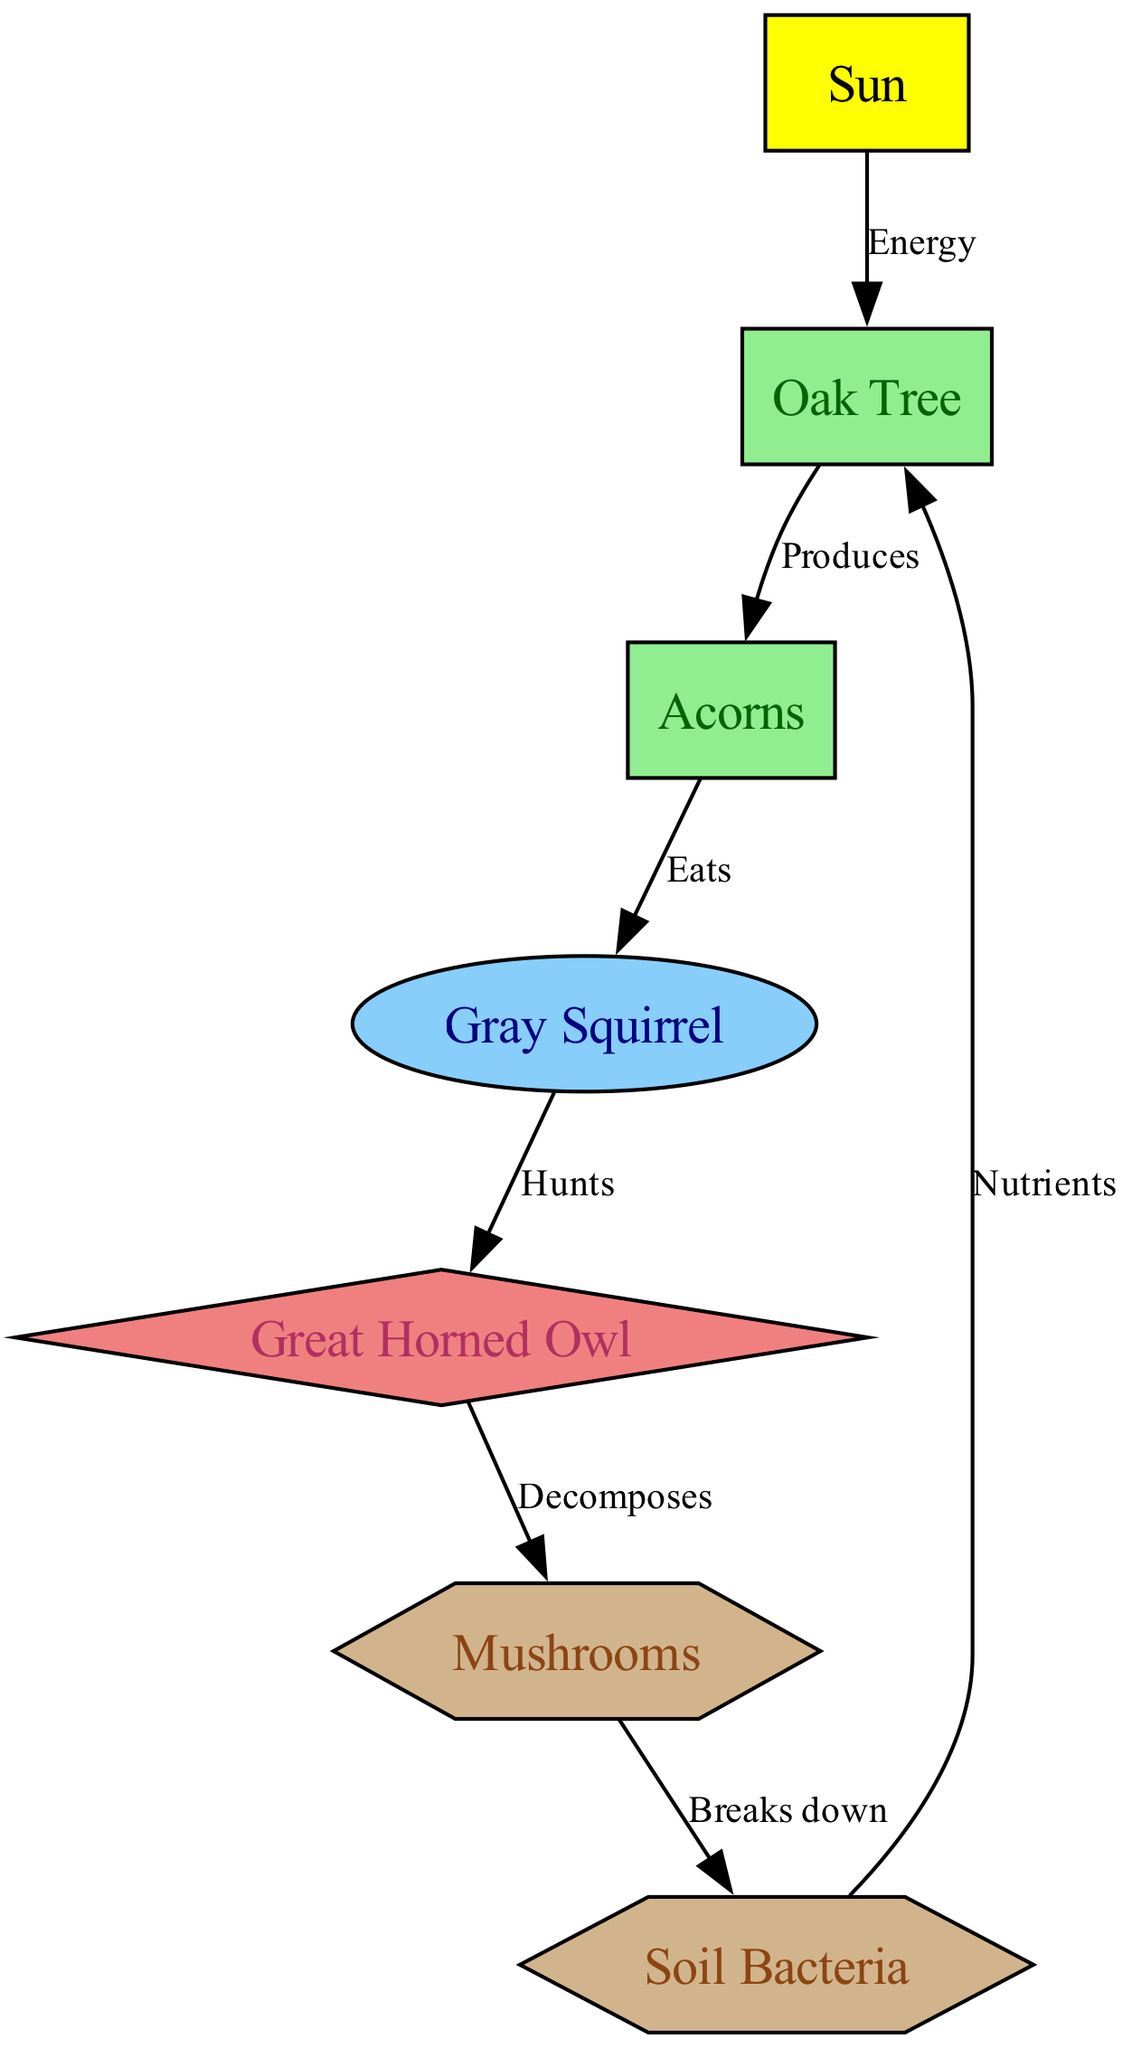What is the primary energy source in the food chain? The diagram indicates that the primary energy source is depicted as the "Sun." This is the starting point of the food chain, providing energy for the producers.
Answer: Sun How many producers are represented in the diagram? By examining the nodes, we can identify "Oak Tree" and "Acorns" as the producers in the food chain. There are two producers in total.
Answer: 2 What does the Gray Squirrel eat? According to the edges in the diagram, the Gray Squirrel specifically "Eats" Acorns. This shows the direct relationship between the herbivore and its food source.
Answer: Acorns Which organism is a carnivore in the diagram? The diagram includes a node labeled "Great Horned Owl," which is identified as the carnivore in the food chain. This indicates its role as a predator of the herbivore.
Answer: Great Horned Owl How do Soil Bacteria contribute to the food chain? The edge labeled "Nutrients" from Soil Bacteria indicates that they break down organic matter, contributing essential nutrients back into the environment, which benefits the producers, notably the Oak Tree.
Answer: Nutrients What role do Mushrooms play in the forest ecosystem? Mushrooms are categorized as decomposers in the diagram, as shown through their label and the connection that illustrates how they break down dead organic matter, enriching the soil.
Answer: Decomposer Which organism has a direct feeding relationship with the owl? The connection labeled "Hunts" between the Gray Squirrel and the Great Horned Owl indicates that the owl directly hunts the squirrel for food, creating a predator-prey relationship.
Answer: Gray Squirrel What relationship exists between fungi and bacteria in the diagram? The edge labeled "Breaks down" illustrates the relationship where fungi decompose organic material and subsequently interact with bacteria, showing the decomposition process and nutrient cycling.
Answer: Breaks down How does energy flow from the Sun to the Gray Squirrel? The flow of energy starts from the "Sun," which energizes the "Oak Tree," leading to the production of "Acorns" that the "Gray Squirrel" ultimately consumes, demonstrating a chain of energy transfer.
Answer: Through Acorns 